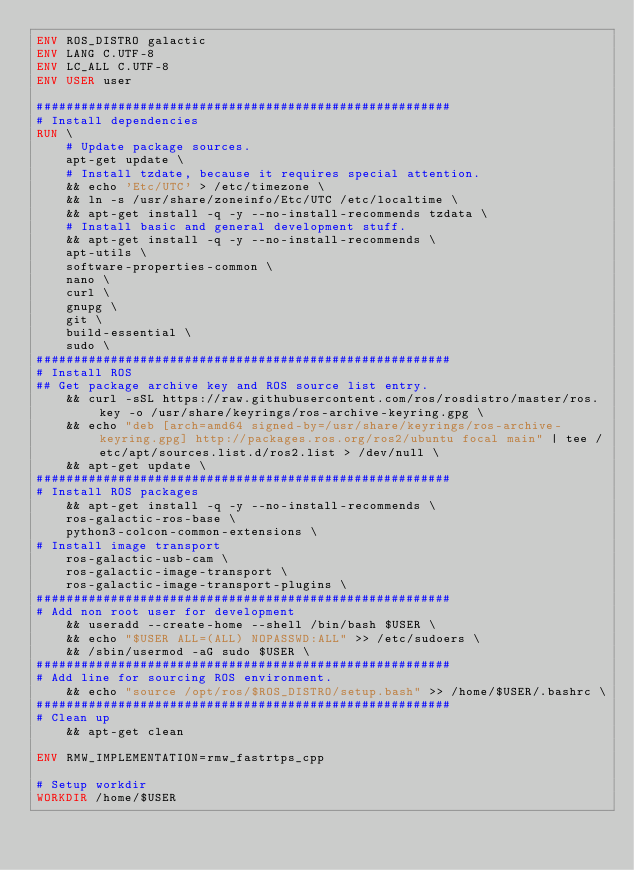Convert code to text. <code><loc_0><loc_0><loc_500><loc_500><_Dockerfile_>ENV ROS_DISTRO galactic
ENV LANG C.UTF-8
ENV LC_ALL C.UTF-8
ENV USER user

########################################################
# Install dependencies
RUN \
    # Update package sources.
    apt-get update \
    # Install tzdate, because it requires special attention.
    && echo 'Etc/UTC' > /etc/timezone \
    && ln -s /usr/share/zoneinfo/Etc/UTC /etc/localtime \
    && apt-get install -q -y --no-install-recommends tzdata \
    # Install basic and general development stuff.
    && apt-get install -q -y --no-install-recommends \
    apt-utils \
    software-properties-common \
    nano \
    curl \
    gnupg \
    git \
    build-essential \
    sudo \
########################################################
# Install ROS
## Get package archive key and ROS source list entry.
    && curl -sSL https://raw.githubusercontent.com/ros/rosdistro/master/ros.key -o /usr/share/keyrings/ros-archive-keyring.gpg \
    && echo "deb [arch=amd64 signed-by=/usr/share/keyrings/ros-archive-keyring.gpg] http://packages.ros.org/ros2/ubuntu focal main" | tee /etc/apt/sources.list.d/ros2.list > /dev/null \
    && apt-get update \
########################################################
# Install ROS packages
    && apt-get install -q -y --no-install-recommends \
    ros-galactic-ros-base \
    python3-colcon-common-extensions \
# Install image transport
    ros-galactic-usb-cam \
    ros-galactic-image-transport \
    ros-galactic-image-transport-plugins \
########################################################
# Add non root user for development
    && useradd --create-home --shell /bin/bash $USER \
    && echo "$USER ALL=(ALL) NOPASSWD:ALL" >> /etc/sudoers \
    && /sbin/usermod -aG sudo $USER \
########################################################
# Add line for sourcing ROS environment.
    && echo "source /opt/ros/$ROS_DISTRO/setup.bash" >> /home/$USER/.bashrc \
########################################################
# Clean up
    && apt-get clean

ENV RMW_IMPLEMENTATION=rmw_fastrtps_cpp

# Setup workdir
WORKDIR /home/$USER

</code> 